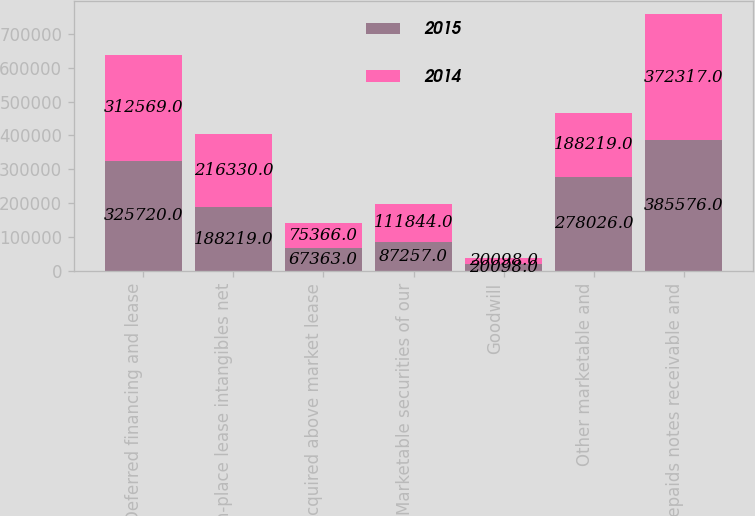Convert chart to OTSL. <chart><loc_0><loc_0><loc_500><loc_500><stacked_bar_chart><ecel><fcel>Deferred financing and lease<fcel>In-place lease intangibles net<fcel>Acquired above market lease<fcel>Marketable securities of our<fcel>Goodwill<fcel>Other marketable and<fcel>Prepaids notes receivable and<nl><fcel>2015<fcel>325720<fcel>188219<fcel>67363<fcel>87257<fcel>20098<fcel>278026<fcel>385576<nl><fcel>2014<fcel>312569<fcel>216330<fcel>75366<fcel>111844<fcel>20098<fcel>188219<fcel>372317<nl></chart> 